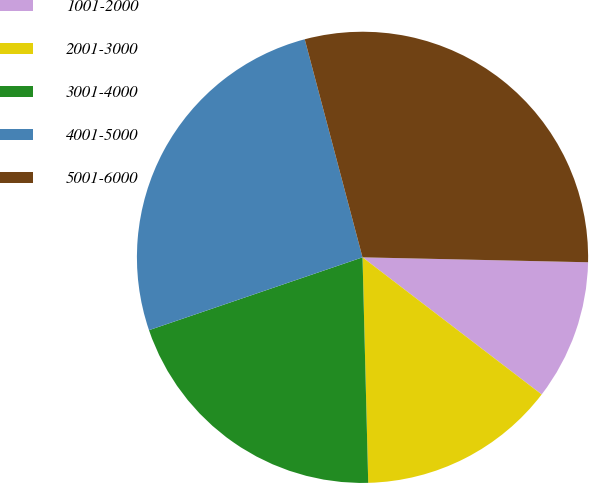Convert chart. <chart><loc_0><loc_0><loc_500><loc_500><pie_chart><fcel>1001-2000<fcel>2001-3000<fcel>3001-4000<fcel>4001-5000<fcel>5001-6000<nl><fcel>10.05%<fcel>14.2%<fcel>20.17%<fcel>26.11%<fcel>29.47%<nl></chart> 